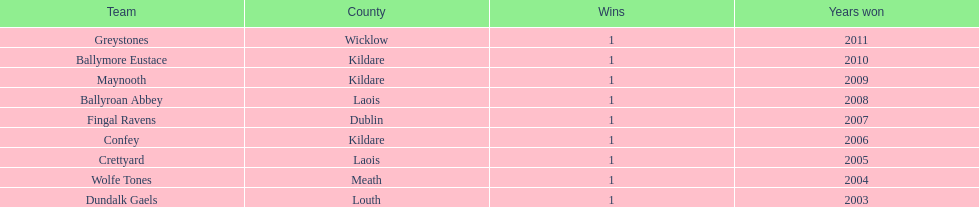Prior to crettyard, which team emerged as the winner? Wolfe Tones. 